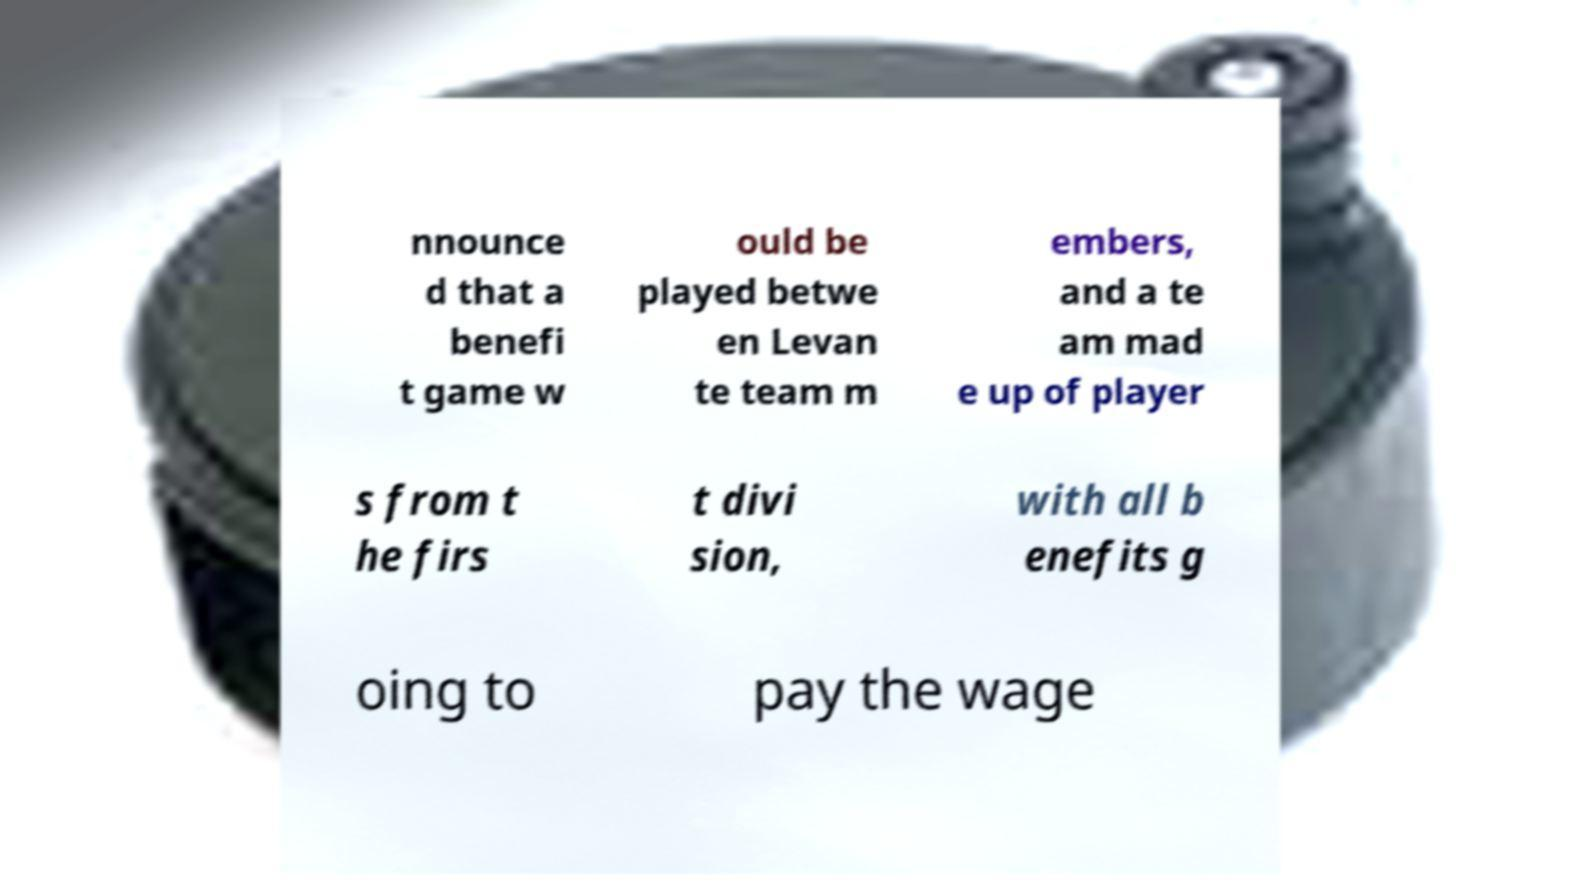Can you read and provide the text displayed in the image?This photo seems to have some interesting text. Can you extract and type it out for me? nnounce d that a benefi t game w ould be played betwe en Levan te team m embers, and a te am mad e up of player s from t he firs t divi sion, with all b enefits g oing to pay the wage 